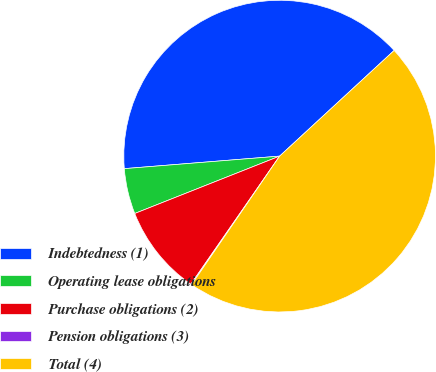Convert chart. <chart><loc_0><loc_0><loc_500><loc_500><pie_chart><fcel>Indebtedness (1)<fcel>Operating lease obligations<fcel>Purchase obligations (2)<fcel>Pension obligations (3)<fcel>Total (4)<nl><fcel>39.42%<fcel>4.72%<fcel>9.35%<fcel>0.09%<fcel>46.42%<nl></chart> 